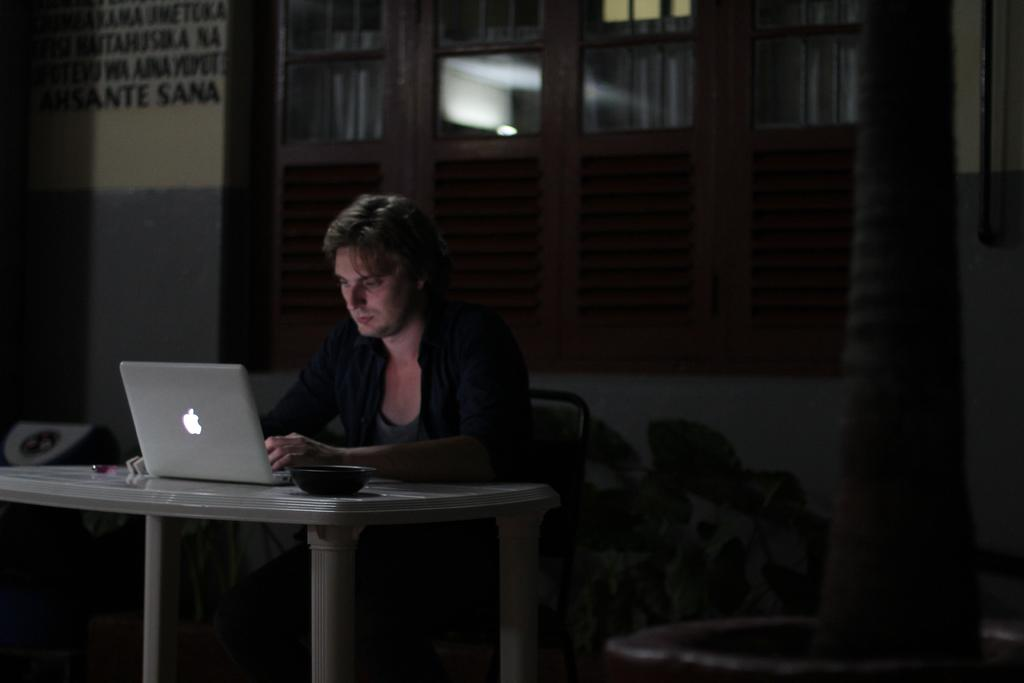Who is present in the image? There is a man in the image. What is the man doing in the image? The man is sitting at a table and working on a laptop. What type of protest is happening in the background of the image? There is no protest present in the image; it only features a man sitting at a table and working on a laptop. 